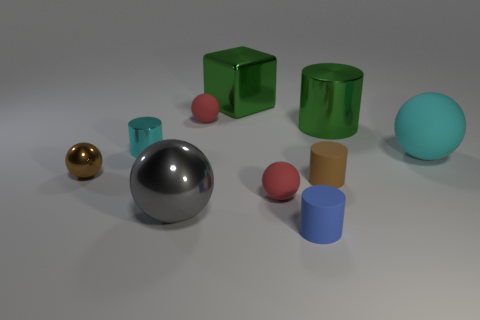Subtract all small brown cylinders. How many cylinders are left? 3 Subtract all cyan cubes. How many red spheres are left? 2 Subtract all cyan cylinders. How many cylinders are left? 3 Subtract 1 balls. How many balls are left? 4 Subtract all cubes. How many objects are left? 9 Subtract all red balls. Subtract all purple cylinders. How many balls are left? 3 Add 7 brown metallic things. How many brown metallic things are left? 8 Add 10 big purple shiny cylinders. How many big purple shiny cylinders exist? 10 Subtract 1 brown cylinders. How many objects are left? 9 Subtract all green metallic cubes. Subtract all small purple metallic spheres. How many objects are left? 9 